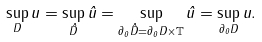<formula> <loc_0><loc_0><loc_500><loc_500>\sup _ { D } u = \sup _ { \hat { D } } \hat { u } = \sup _ { \partial _ { 0 } \hat { D } = \partial _ { 0 } D \times \mathbb { T } } \hat { u } = \sup _ { \partial _ { 0 } D } u .</formula> 